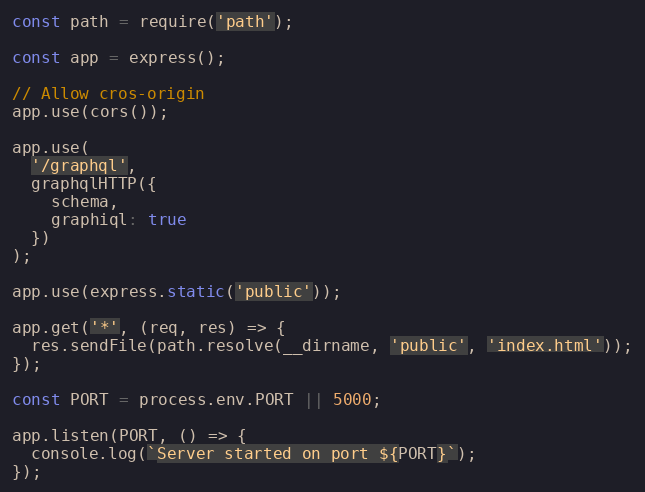Convert code to text. <code><loc_0><loc_0><loc_500><loc_500><_JavaScript_>const path = require('path');

const app = express();

// Allow cros-origin
app.use(cors());

app.use(
  '/graphql',
  graphqlHTTP({
    schema,
    graphiql: true
  })
);

app.use(express.static('public'));

app.get('*', (req, res) => {
  res.sendFile(path.resolve(__dirname, 'public', 'index.html'));
});

const PORT = process.env.PORT || 5000;

app.listen(PORT, () => {
  console.log(`Server started on port ${PORT}`);
});
</code> 